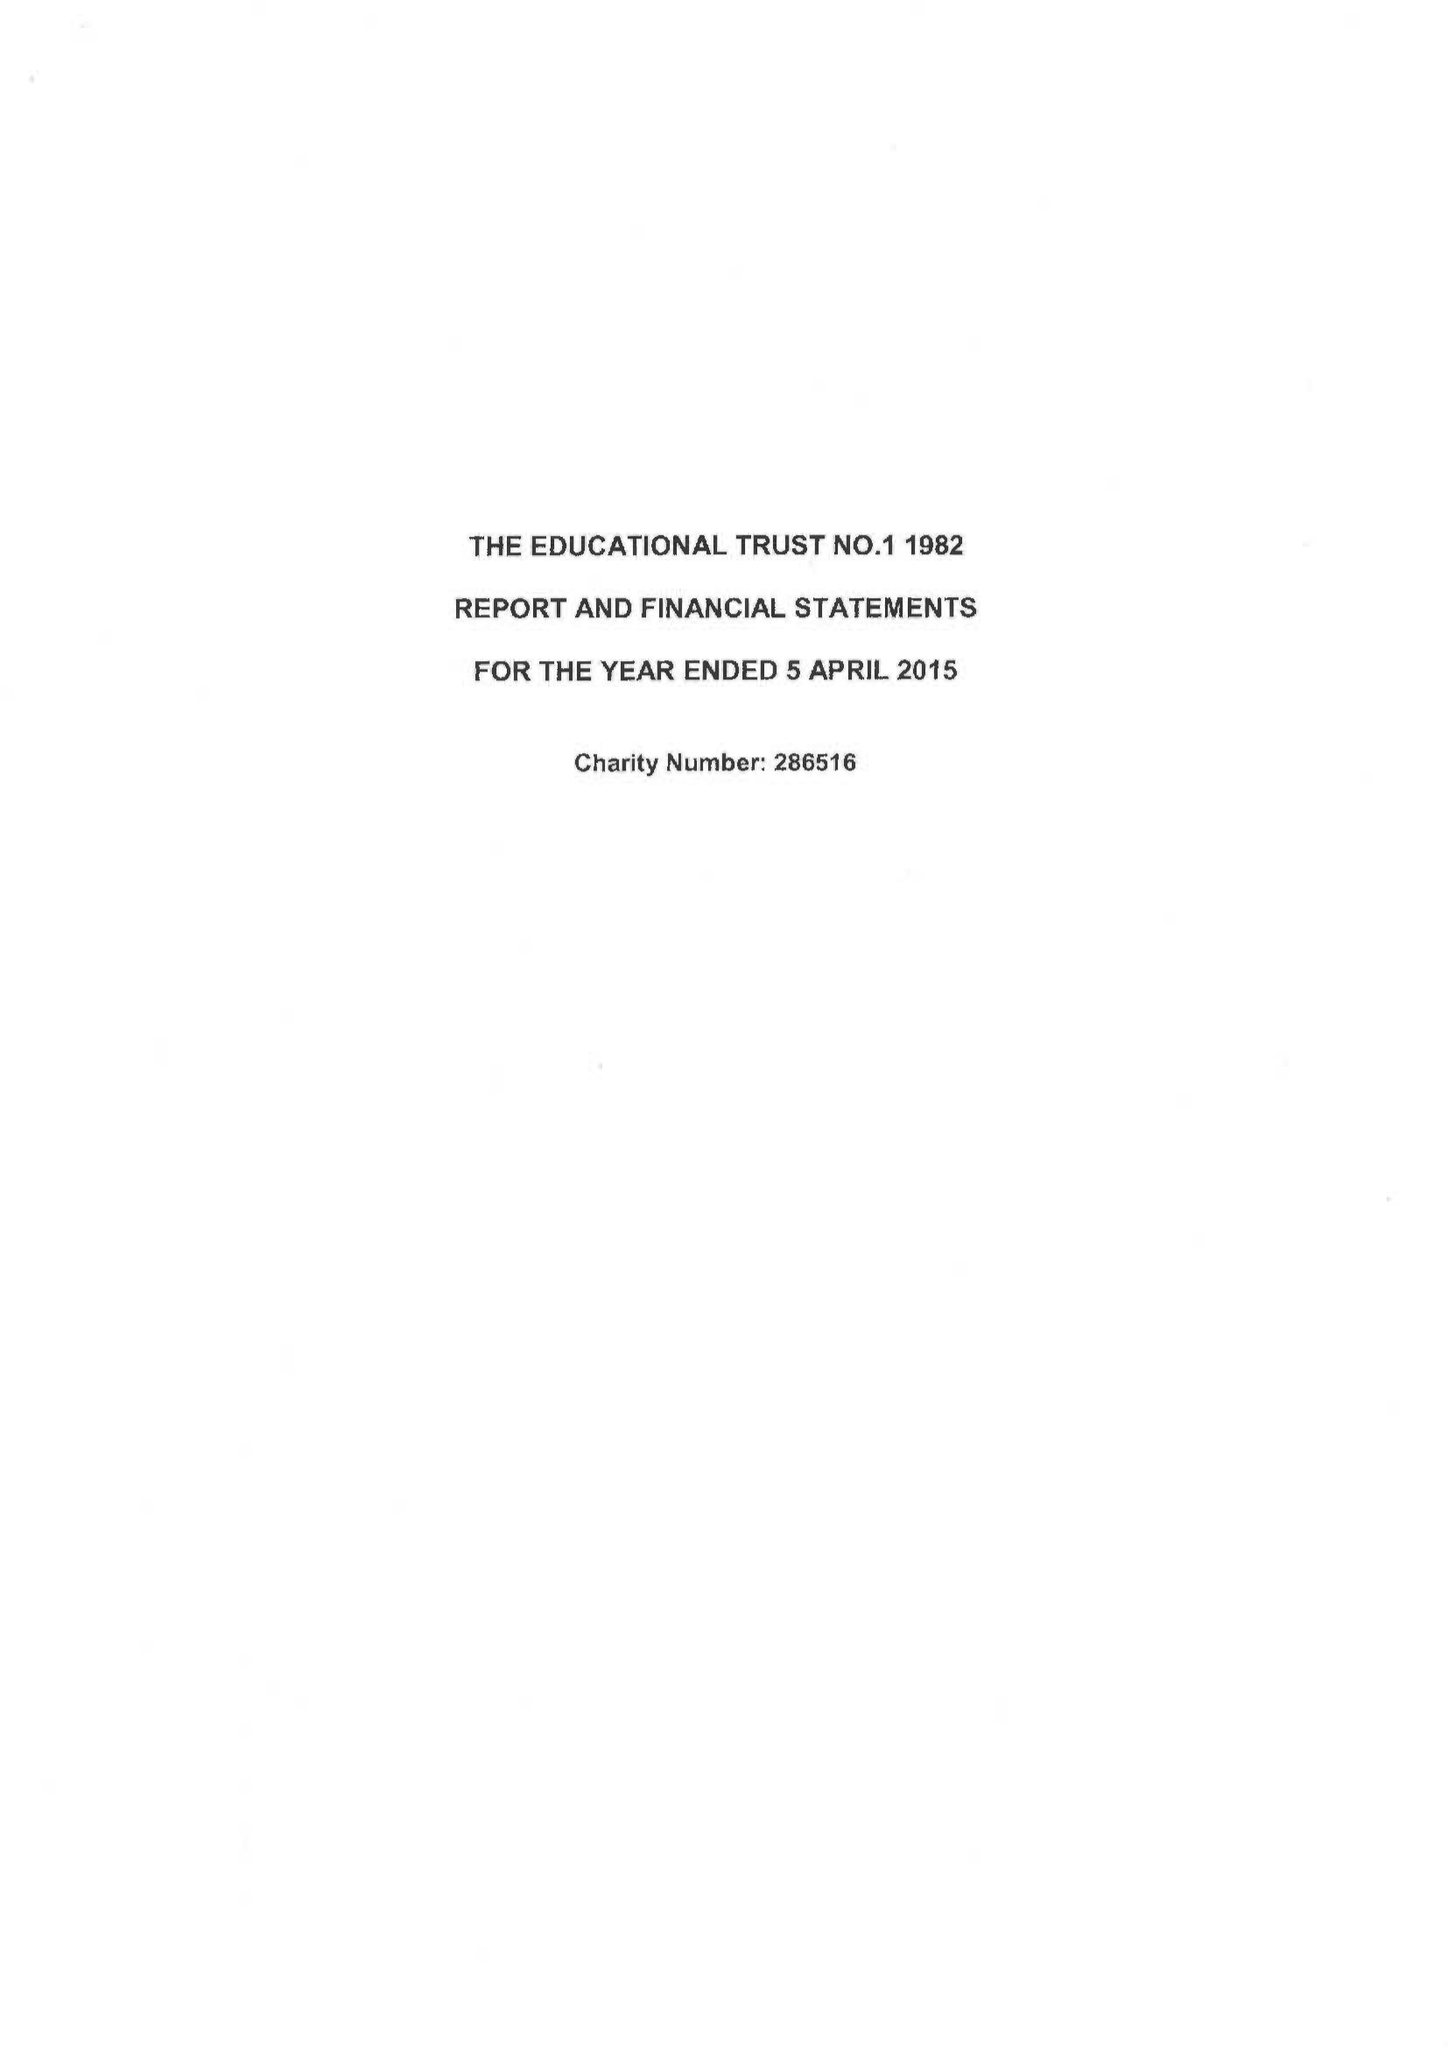What is the value for the address__street_line?
Answer the question using a single word or phrase. THE FORUM PARKWAY 